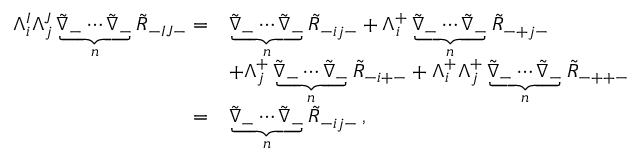Convert formula to latex. <formula><loc_0><loc_0><loc_500><loc_500>\begin{array} { r l } { \Lambda ^ { I } _ { i } \Lambda ^ { J } _ { j } \underbrace { \tilde { \nabla } _ { - } \cdots \tilde { \nabla } _ { - } } _ { n } \tilde { R } _ { - I J - } = } & { \underbrace { \tilde { \nabla } _ { - } \cdots \tilde { \nabla } _ { - } } _ { n } \tilde { R } _ { - i j - } + \Lambda ^ { + } _ { i } \underbrace { \tilde { \nabla } _ { - } \cdots \tilde { \nabla } _ { - } } _ { n } \tilde { R } _ { - + j - } } \\ & { + \Lambda ^ { + } _ { j } \underbrace { \tilde { \nabla } _ { - } \cdots \tilde { \nabla } _ { - } } _ { n } \tilde { R } _ { - i + - } + \Lambda ^ { + } _ { i } \Lambda ^ { + } _ { j } \underbrace { \tilde { \nabla } _ { - } \cdots \tilde { \nabla } _ { - } } _ { n } \tilde { R } _ { - + + - } } \\ { = } & { \underbrace { \tilde { \nabla } _ { - } \cdots \tilde { \nabla } _ { - } } _ { n } \tilde { R } _ { - i j - } \, , } \end{array}</formula> 